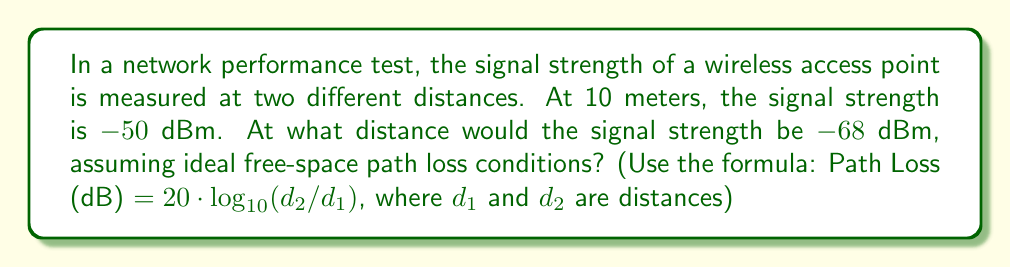Give your solution to this math problem. Let's approach this step-by-step:

1) We know that the signal strength at 10 meters is -50 dBm, and we're looking for the distance where it's -68 dBm.

2) The difference in signal strength is:
   $$ -68 \text{ dBm} - (-50 \text{ dBm}) = -18 \text{ dB} $$

3) This -18 dB represents the additional path loss. We can use the given formula:
   $$ \text{Path Loss (dB)} = 20 * \log_{10}(d_2/d_1) $$

4) Substituting our values:
   $$ -18 = 20 * \log_{10}(d_2/10) $$

5) Dividing both sides by 20:
   $$ -0.9 = \log_{10}(d_2/10) $$

6) Taking 10 to the power of both sides:
   $$ 10^{-0.9} = d_2/10 $$

7) Simplifying:
   $$ 0.12589 = d_2/10 $$

8) Multiplying both sides by 10:
   $$ d_2 = 0.12589 * 10 = 1.2589 $$

Therefore, the distance $d_2$ is approximately 39.81 meters.

For Python or PowerShell scripting, you could implement this calculation using the math library's log10 and pow functions.
Answer: 39.81 meters 